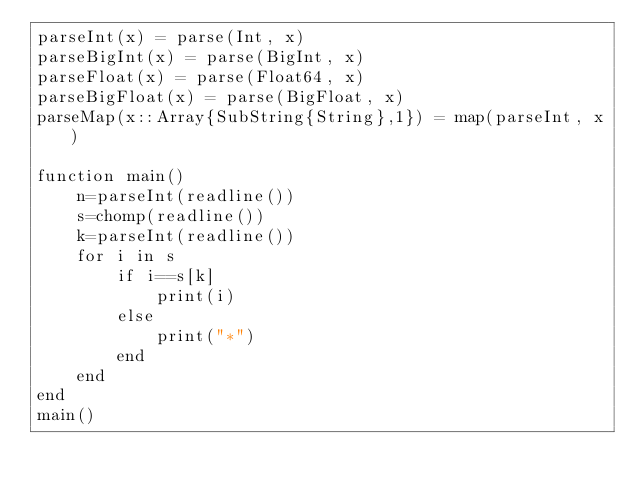<code> <loc_0><loc_0><loc_500><loc_500><_Julia_>parseInt(x) = parse(Int, x)
parseBigInt(x) = parse(BigInt, x)
parseFloat(x) = parse(Float64, x)
parseBigFloat(x) = parse(BigFloat, x)
parseMap(x::Array{SubString{String},1}) = map(parseInt, x)

function main()
    n=parseInt(readline())
    s=chomp(readline())
    k=parseInt(readline())
    for i in s
        if i==s[k]
            print(i)
        else
            print("*")
        end
    end
end
main()</code> 